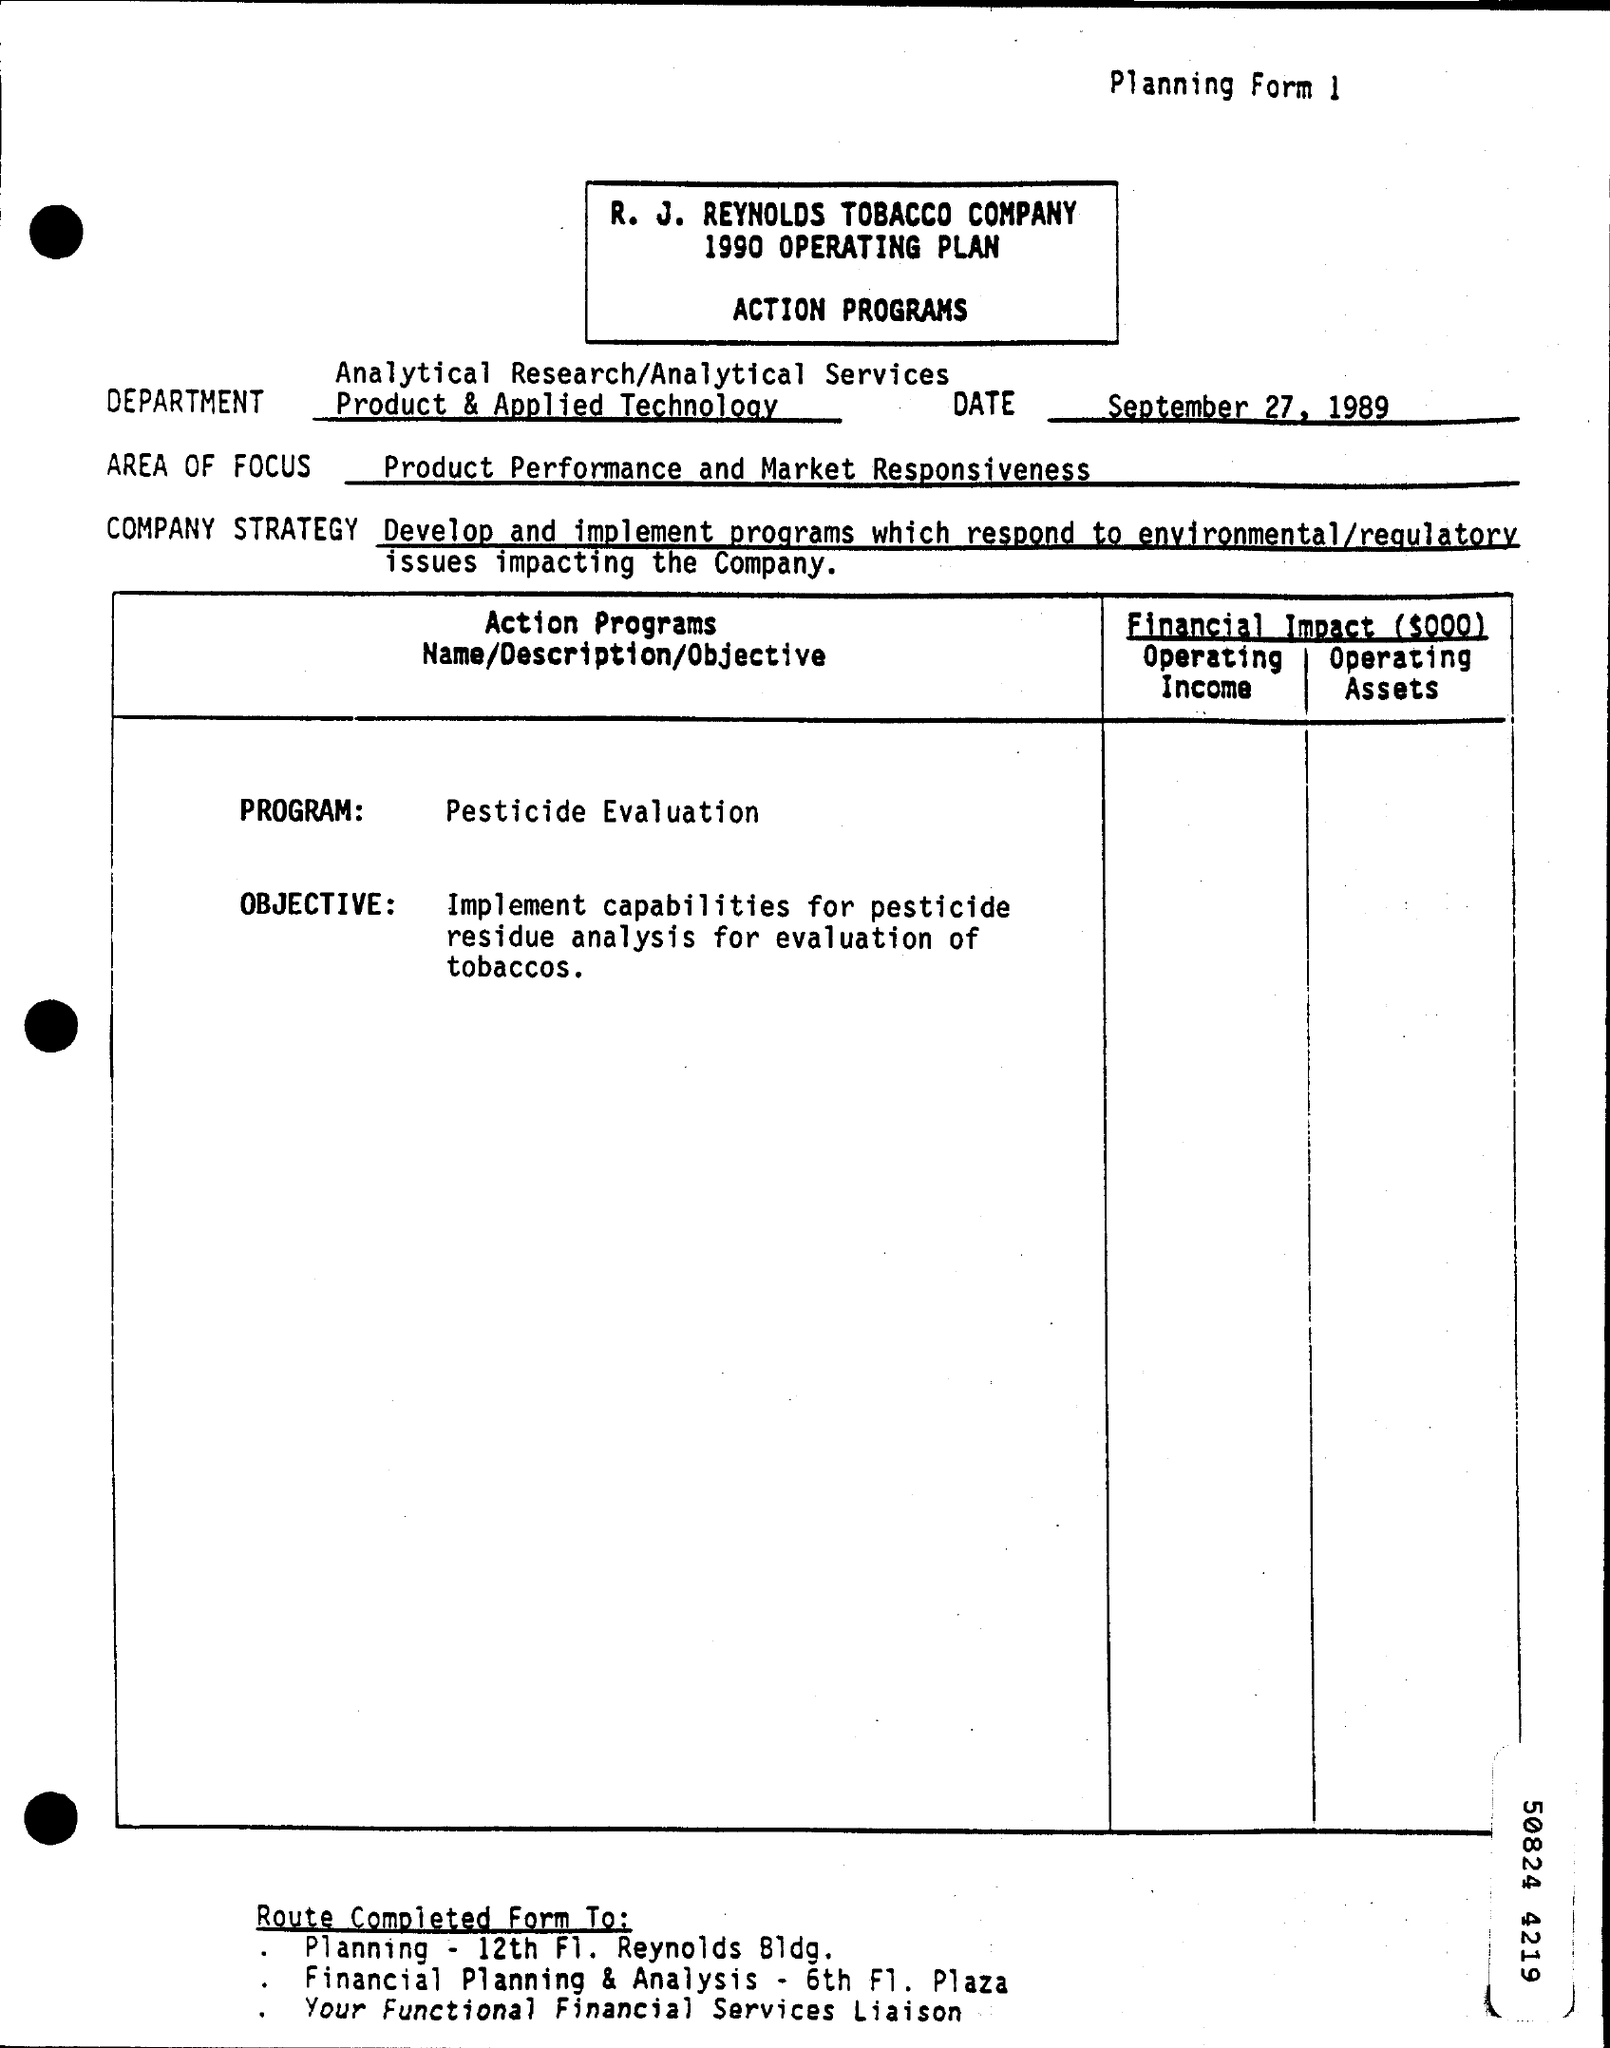Find the date from the page?
Provide a succinct answer. September 27, 1989. 